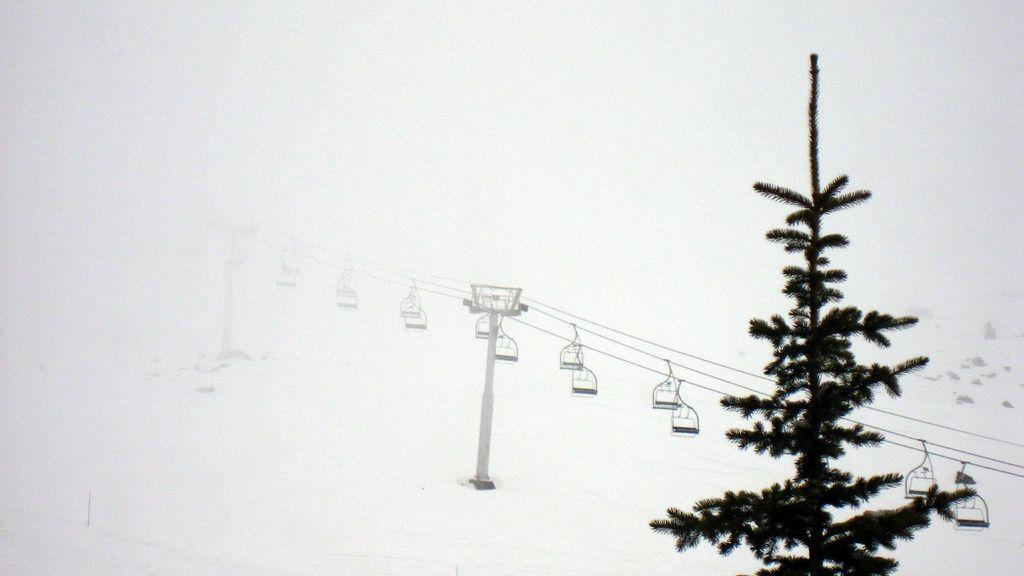What type of natural element is present in the image? There is a tree in the image. What man-made structure can be seen in the image? There is a ropeway in the image. What color is the background of the image? The background of the image is white. What type of cream is being used to decorate the cakes in the image? There are no cakes or cream present in the image; it features a tree and a ropeway with a white background. 